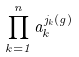Convert formula to latex. <formula><loc_0><loc_0><loc_500><loc_500>\prod _ { k = 1 } ^ { n } a _ { k } ^ { j _ { k } ( g ) }</formula> 